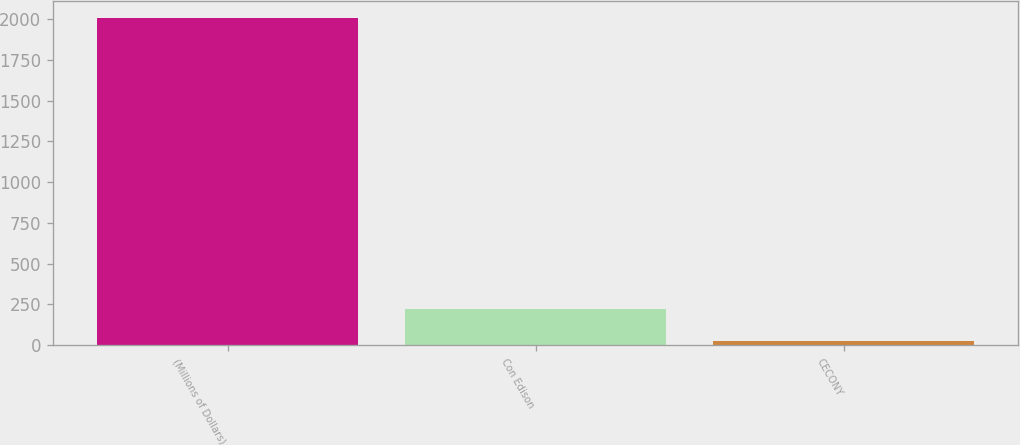<chart> <loc_0><loc_0><loc_500><loc_500><bar_chart><fcel>(Millions of Dollars)<fcel>Con Edison<fcel>CECONY<nl><fcel>2009<fcel>223.4<fcel>25<nl></chart> 